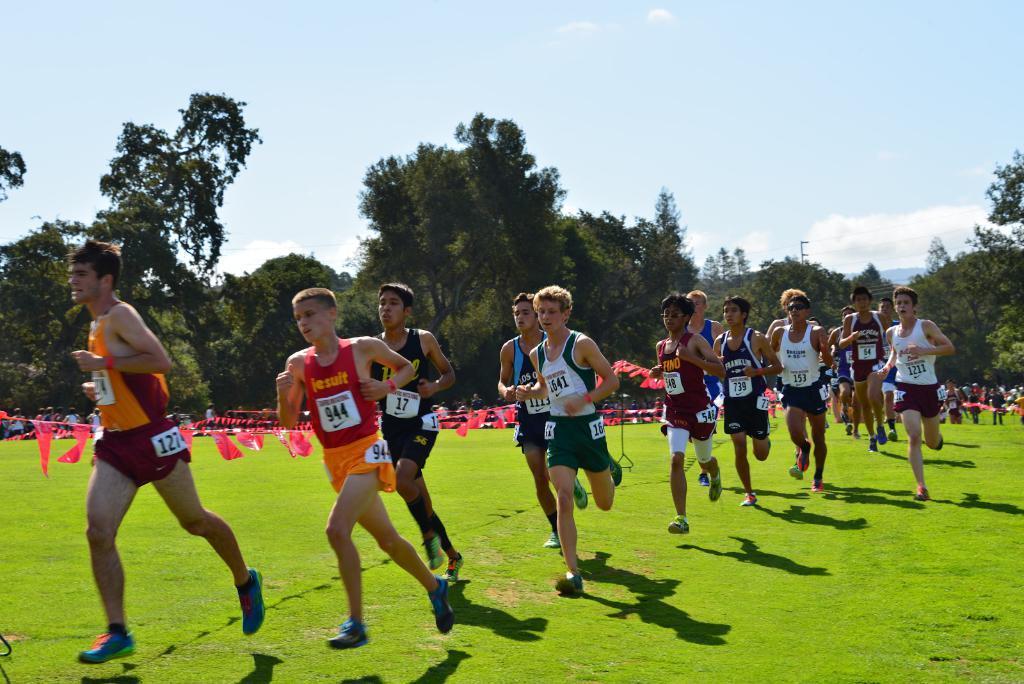Describe this image in one or two sentences. People are running on the grass. There are red flags and trees at the back. 